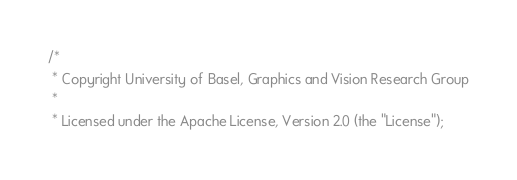Convert code to text. <code><loc_0><loc_0><loc_500><loc_500><_Scala_>/*
 * Copyright University of Basel, Graphics and Vision Research Group
 *
 * Licensed under the Apache License, Version 2.0 (the "License");</code> 